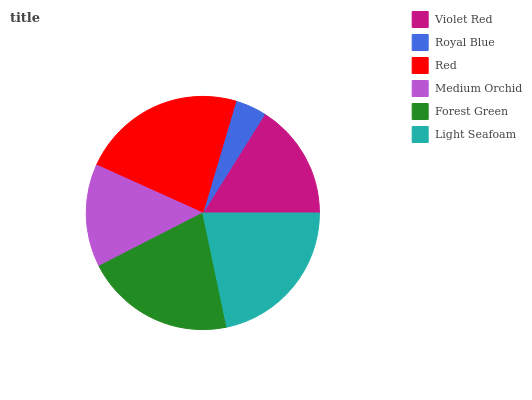Is Royal Blue the minimum?
Answer yes or no. Yes. Is Red the maximum?
Answer yes or no. Yes. Is Red the minimum?
Answer yes or no. No. Is Royal Blue the maximum?
Answer yes or no. No. Is Red greater than Royal Blue?
Answer yes or no. Yes. Is Royal Blue less than Red?
Answer yes or no. Yes. Is Royal Blue greater than Red?
Answer yes or no. No. Is Red less than Royal Blue?
Answer yes or no. No. Is Forest Green the high median?
Answer yes or no. Yes. Is Violet Red the low median?
Answer yes or no. Yes. Is Royal Blue the high median?
Answer yes or no. No. Is Royal Blue the low median?
Answer yes or no. No. 